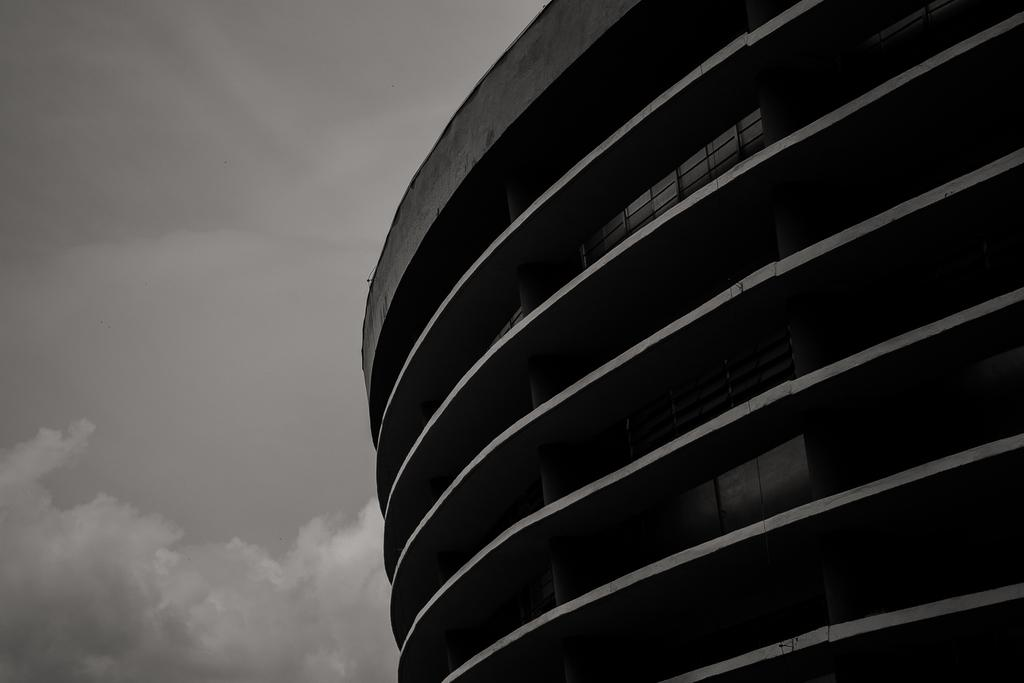What type of structure is present in the image? There is a building in the image. What can be seen in the background of the image? The sky is visible in the background of the image. What type of credit can be seen on the building in the image? There is no credit visible on the building in the image. What is the reaction of the building to the weather in the image? Buildings do not have reactions; they are inanimate objects. 